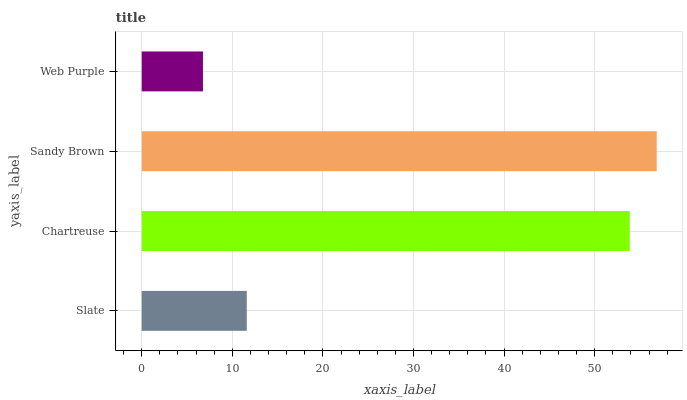Is Web Purple the minimum?
Answer yes or no. Yes. Is Sandy Brown the maximum?
Answer yes or no. Yes. Is Chartreuse the minimum?
Answer yes or no. No. Is Chartreuse the maximum?
Answer yes or no. No. Is Chartreuse greater than Slate?
Answer yes or no. Yes. Is Slate less than Chartreuse?
Answer yes or no. Yes. Is Slate greater than Chartreuse?
Answer yes or no. No. Is Chartreuse less than Slate?
Answer yes or no. No. Is Chartreuse the high median?
Answer yes or no. Yes. Is Slate the low median?
Answer yes or no. Yes. Is Sandy Brown the high median?
Answer yes or no. No. Is Web Purple the low median?
Answer yes or no. No. 